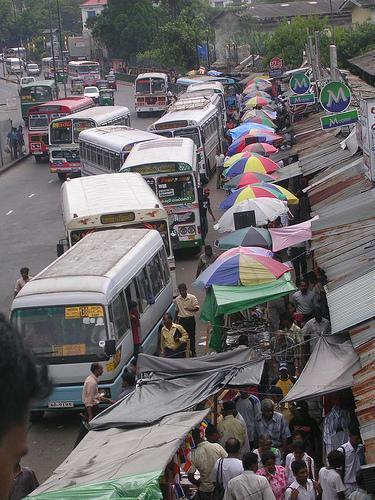How many red busses are in the picture?
Give a very brief answer. 1. How many red bus are driving on the road?
Give a very brief answer. 1. 